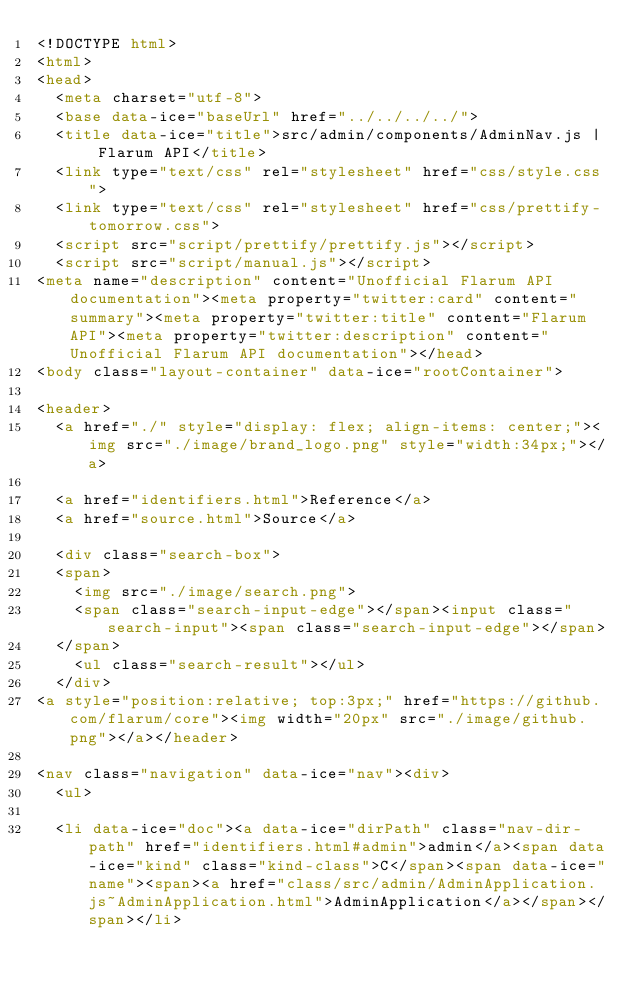Convert code to text. <code><loc_0><loc_0><loc_500><loc_500><_HTML_><!DOCTYPE html>
<html>
<head>
  <meta charset="utf-8">
  <base data-ice="baseUrl" href="../../../../">
  <title data-ice="title">src/admin/components/AdminNav.js | Flarum API</title>
  <link type="text/css" rel="stylesheet" href="css/style.css">
  <link type="text/css" rel="stylesheet" href="css/prettify-tomorrow.css">
  <script src="script/prettify/prettify.js"></script>
  <script src="script/manual.js"></script>
<meta name="description" content="Unofficial Flarum API documentation"><meta property="twitter:card" content="summary"><meta property="twitter:title" content="Flarum API"><meta property="twitter:description" content="Unofficial Flarum API documentation"></head>
<body class="layout-container" data-ice="rootContainer">

<header>
  <a href="./" style="display: flex; align-items: center;"><img src="./image/brand_logo.png" style="width:34px;"></a>
  
  <a href="identifiers.html">Reference</a>
  <a href="source.html">Source</a>
  
  <div class="search-box">
  <span>
    <img src="./image/search.png">
    <span class="search-input-edge"></span><input class="search-input"><span class="search-input-edge"></span>
  </span>
    <ul class="search-result"></ul>
  </div>
<a style="position:relative; top:3px;" href="https://github.com/flarum/core"><img width="20px" src="./image/github.png"></a></header>

<nav class="navigation" data-ice="nav"><div>
  <ul>
    
  <li data-ice="doc"><a data-ice="dirPath" class="nav-dir-path" href="identifiers.html#admin">admin</a><span data-ice="kind" class="kind-class">C</span><span data-ice="name"><span><a href="class/src/admin/AdminApplication.js~AdminApplication.html">AdminApplication</a></span></span></li></code> 